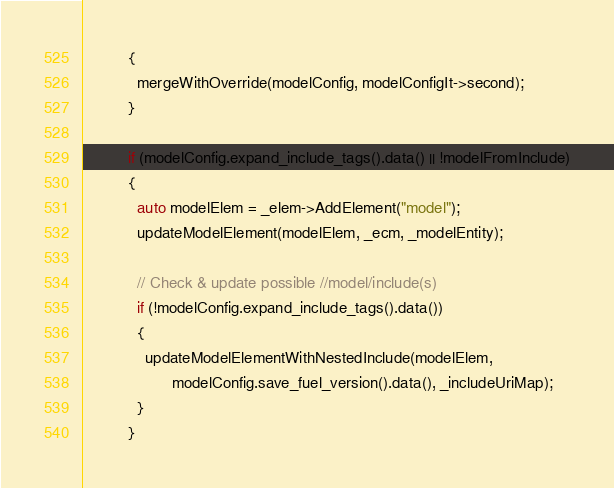Convert code to text. <code><loc_0><loc_0><loc_500><loc_500><_C++_>          {
            mergeWithOverride(modelConfig, modelConfigIt->second);
          }

          if (modelConfig.expand_include_tags().data() || !modelFromInclude)
          {
            auto modelElem = _elem->AddElement("model");
            updateModelElement(modelElem, _ecm, _modelEntity);

            // Check & update possible //model/include(s)
            if (!modelConfig.expand_include_tags().data())
            {
              updateModelElementWithNestedInclude(modelElem,
                    modelConfig.save_fuel_version().data(), _includeUriMap);
            }
          }</code> 